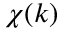<formula> <loc_0><loc_0><loc_500><loc_500>\chi ( k )</formula> 